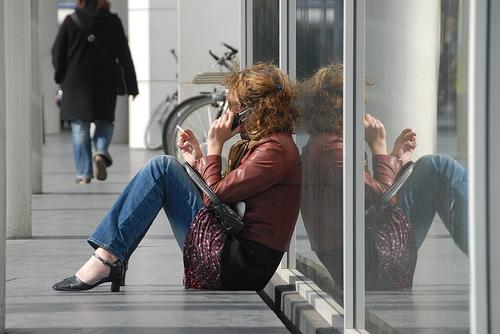What is the woman holding in her left hand?
Short answer required. Phone. Did she just wake up?
Be succinct. No. Is this woman smoking?
Short answer required. Yes. What color is her hair?
Concise answer only. Red. 